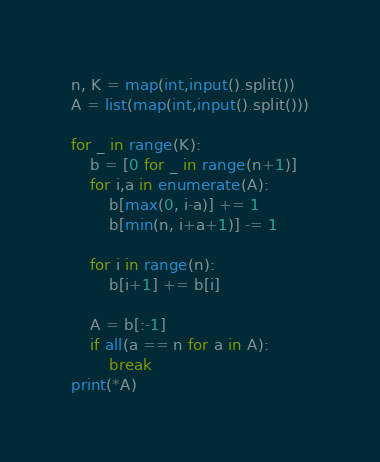Convert code to text. <code><loc_0><loc_0><loc_500><loc_500><_Python_>n, K = map(int,input().split())
A = list(map(int,input().split()))

for _ in range(K):
    b = [0 for _ in range(n+1)]
    for i,a in enumerate(A):
        b[max(0, i-a)] += 1
        b[min(n, i+a+1)] -= 1

    for i in range(n):
        b[i+1] += b[i]

    A = b[:-1]
    if all(a == n for a in A):
        break
print(*A)</code> 